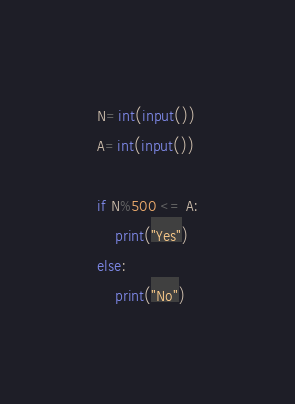<code> <loc_0><loc_0><loc_500><loc_500><_Python_>N=int(input())
A=int(input())

if N%500 <= A:
    print("Yes")
else:
    print("No")</code> 